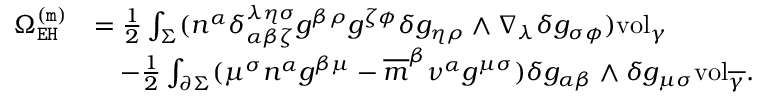<formula> <loc_0><loc_0><loc_500><loc_500>\begin{array} { r l } { \Omega _ { E H } ^ { ( m ) } } & { = \frac { 1 } { 2 } \int _ { \Sigma } ( n ^ { \alpha } \delta _ { \alpha \beta \zeta } ^ { \lambda \eta \sigma } g ^ { \beta \rho } g ^ { \zeta \phi } \delta g _ { \eta \rho } \wedge \nabla _ { \lambda } \delta g _ { \sigma \phi } ) v o l _ { \gamma } } \\ & { \quad - \frac { 1 } { 2 } \int _ { \partial \Sigma } ( \mu ^ { \sigma } n ^ { \alpha } g ^ { \beta \mu } - \overline { m } ^ { \beta } \nu ^ { \alpha } g ^ { \mu \sigma } ) \delta g _ { \alpha \beta } \wedge \delta g _ { \mu \sigma } v o l _ { \overline { \gamma } } . } \end{array}</formula> 